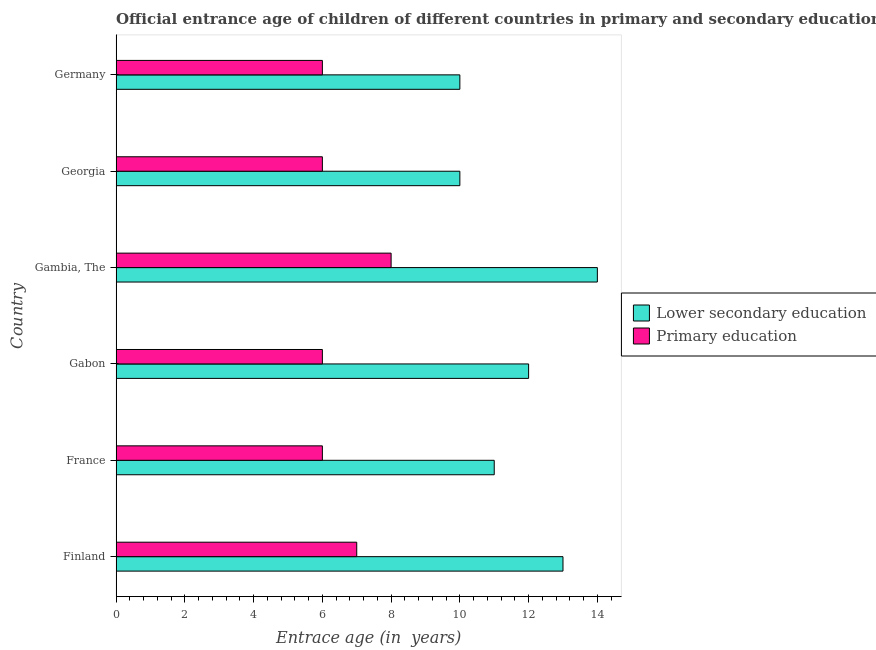How many different coloured bars are there?
Your response must be concise. 2. How many bars are there on the 4th tick from the bottom?
Your answer should be very brief. 2. What is the label of the 4th group of bars from the top?
Keep it short and to the point. Gabon. In how many cases, is the number of bars for a given country not equal to the number of legend labels?
Provide a succinct answer. 0. What is the entrance age of children in lower secondary education in Gabon?
Your answer should be very brief. 12. Across all countries, what is the maximum entrance age of chiildren in primary education?
Your response must be concise. 8. Across all countries, what is the minimum entrance age of chiildren in primary education?
Your answer should be compact. 6. In which country was the entrance age of chiildren in primary education maximum?
Your answer should be compact. Gambia, The. In which country was the entrance age of children in lower secondary education minimum?
Make the answer very short. Georgia. What is the total entrance age of children in lower secondary education in the graph?
Give a very brief answer. 70. What is the difference between the entrance age of children in lower secondary education in France and that in Gambia, The?
Provide a succinct answer. -3. What is the difference between the entrance age of children in lower secondary education in Georgia and the entrance age of chiildren in primary education in Gabon?
Ensure brevity in your answer.  4. What is the average entrance age of children in lower secondary education per country?
Offer a very short reply. 11.67. What is the difference between the entrance age of chiildren in primary education and entrance age of children in lower secondary education in Gambia, The?
Provide a succinct answer. -6. What is the ratio of the entrance age of children in lower secondary education in Gabon to that in Gambia, The?
Your answer should be compact. 0.86. Is the entrance age of chiildren in primary education in France less than that in Georgia?
Provide a succinct answer. No. What is the difference between the highest and the lowest entrance age of chiildren in primary education?
Offer a terse response. 2. Is the sum of the entrance age of children in lower secondary education in France and Gabon greater than the maximum entrance age of chiildren in primary education across all countries?
Your answer should be very brief. Yes. What does the 2nd bar from the top in Gambia, The represents?
Keep it short and to the point. Lower secondary education. What does the 1st bar from the bottom in France represents?
Give a very brief answer. Lower secondary education. How many bars are there?
Provide a succinct answer. 12. Are all the bars in the graph horizontal?
Your answer should be compact. Yes. How many countries are there in the graph?
Offer a very short reply. 6. What is the difference between two consecutive major ticks on the X-axis?
Keep it short and to the point. 2. Are the values on the major ticks of X-axis written in scientific E-notation?
Keep it short and to the point. No. Does the graph contain grids?
Offer a very short reply. No. Where does the legend appear in the graph?
Your answer should be very brief. Center right. How are the legend labels stacked?
Keep it short and to the point. Vertical. What is the title of the graph?
Offer a terse response. Official entrance age of children of different countries in primary and secondary education. What is the label or title of the X-axis?
Your answer should be very brief. Entrace age (in  years). What is the label or title of the Y-axis?
Ensure brevity in your answer.  Country. What is the Entrace age (in  years) of Lower secondary education in Gabon?
Ensure brevity in your answer.  12. What is the Entrace age (in  years) of Primary education in Gambia, The?
Your answer should be compact. 8. What is the Entrace age (in  years) of Lower secondary education in Georgia?
Your answer should be very brief. 10. What is the Entrace age (in  years) of Primary education in Georgia?
Ensure brevity in your answer.  6. What is the Entrace age (in  years) of Lower secondary education in Germany?
Make the answer very short. 10. What is the Entrace age (in  years) in Primary education in Germany?
Offer a very short reply. 6. Across all countries, what is the maximum Entrace age (in  years) in Lower secondary education?
Keep it short and to the point. 14. Across all countries, what is the minimum Entrace age (in  years) in Lower secondary education?
Make the answer very short. 10. What is the difference between the Entrace age (in  years) of Primary education in Finland and that in France?
Keep it short and to the point. 1. What is the difference between the Entrace age (in  years) of Lower secondary education in Finland and that in Gabon?
Offer a terse response. 1. What is the difference between the Entrace age (in  years) in Lower secondary education in Finland and that in Gambia, The?
Ensure brevity in your answer.  -1. What is the difference between the Entrace age (in  years) in Lower secondary education in Finland and that in Georgia?
Keep it short and to the point. 3. What is the difference between the Entrace age (in  years) in Lower secondary education in Finland and that in Germany?
Your answer should be very brief. 3. What is the difference between the Entrace age (in  years) of Primary education in France and that in Gambia, The?
Your answer should be compact. -2. What is the difference between the Entrace age (in  years) of Lower secondary education in France and that in Georgia?
Offer a very short reply. 1. What is the difference between the Entrace age (in  years) in Lower secondary education in Gabon and that in Gambia, The?
Keep it short and to the point. -2. What is the difference between the Entrace age (in  years) of Primary education in Gabon and that in Gambia, The?
Keep it short and to the point. -2. What is the difference between the Entrace age (in  years) of Primary education in Gabon and that in Georgia?
Your answer should be very brief. 0. What is the difference between the Entrace age (in  years) of Lower secondary education in Gambia, The and that in Georgia?
Offer a very short reply. 4. What is the difference between the Entrace age (in  years) in Lower secondary education in Gambia, The and that in Germany?
Offer a very short reply. 4. What is the difference between the Entrace age (in  years) of Primary education in Georgia and that in Germany?
Make the answer very short. 0. What is the difference between the Entrace age (in  years) of Lower secondary education in Finland and the Entrace age (in  years) of Primary education in France?
Offer a terse response. 7. What is the difference between the Entrace age (in  years) in Lower secondary education in Finland and the Entrace age (in  years) in Primary education in Gambia, The?
Provide a short and direct response. 5. What is the difference between the Entrace age (in  years) in Lower secondary education in Finland and the Entrace age (in  years) in Primary education in Germany?
Provide a short and direct response. 7. What is the difference between the Entrace age (in  years) of Lower secondary education in France and the Entrace age (in  years) of Primary education in Gabon?
Offer a very short reply. 5. What is the difference between the Entrace age (in  years) in Lower secondary education in France and the Entrace age (in  years) in Primary education in Gambia, The?
Ensure brevity in your answer.  3. What is the difference between the Entrace age (in  years) of Lower secondary education in France and the Entrace age (in  years) of Primary education in Georgia?
Your answer should be compact. 5. What is the difference between the Entrace age (in  years) of Lower secondary education in Gabon and the Entrace age (in  years) of Primary education in Gambia, The?
Offer a terse response. 4. What is the difference between the Entrace age (in  years) in Lower secondary education in Gabon and the Entrace age (in  years) in Primary education in Georgia?
Your response must be concise. 6. What is the difference between the Entrace age (in  years) of Lower secondary education in Gambia, The and the Entrace age (in  years) of Primary education in Georgia?
Make the answer very short. 8. What is the difference between the Entrace age (in  years) in Lower secondary education in Gambia, The and the Entrace age (in  years) in Primary education in Germany?
Make the answer very short. 8. What is the average Entrace age (in  years) in Lower secondary education per country?
Offer a terse response. 11.67. What is the difference between the Entrace age (in  years) of Lower secondary education and Entrace age (in  years) of Primary education in France?
Offer a very short reply. 5. What is the difference between the Entrace age (in  years) in Lower secondary education and Entrace age (in  years) in Primary education in Gambia, The?
Ensure brevity in your answer.  6. What is the difference between the Entrace age (in  years) of Lower secondary education and Entrace age (in  years) of Primary education in Germany?
Make the answer very short. 4. What is the ratio of the Entrace age (in  years) in Lower secondary education in Finland to that in France?
Provide a succinct answer. 1.18. What is the ratio of the Entrace age (in  years) of Primary education in Finland to that in France?
Your answer should be very brief. 1.17. What is the ratio of the Entrace age (in  years) in Lower secondary education in Finland to that in Gabon?
Give a very brief answer. 1.08. What is the ratio of the Entrace age (in  years) in Primary education in Finland to that in Gambia, The?
Your response must be concise. 0.88. What is the ratio of the Entrace age (in  years) in Lower secondary education in Finland to that in Georgia?
Your response must be concise. 1.3. What is the ratio of the Entrace age (in  years) in Primary education in Finland to that in Georgia?
Your answer should be very brief. 1.17. What is the ratio of the Entrace age (in  years) in Primary education in Finland to that in Germany?
Your response must be concise. 1.17. What is the ratio of the Entrace age (in  years) of Primary education in France to that in Gabon?
Ensure brevity in your answer.  1. What is the ratio of the Entrace age (in  years) in Lower secondary education in France to that in Gambia, The?
Keep it short and to the point. 0.79. What is the ratio of the Entrace age (in  years) of Lower secondary education in France to that in Georgia?
Your response must be concise. 1.1. What is the ratio of the Entrace age (in  years) of Lower secondary education in France to that in Germany?
Offer a very short reply. 1.1. What is the ratio of the Entrace age (in  years) in Primary education in France to that in Germany?
Provide a succinct answer. 1. What is the ratio of the Entrace age (in  years) of Lower secondary education in Gambia, The to that in Georgia?
Your response must be concise. 1.4. What is the ratio of the Entrace age (in  years) of Primary education in Gambia, The to that in Georgia?
Your answer should be compact. 1.33. What is the ratio of the Entrace age (in  years) of Lower secondary education in Gambia, The to that in Germany?
Your answer should be compact. 1.4. What is the ratio of the Entrace age (in  years) of Lower secondary education in Georgia to that in Germany?
Make the answer very short. 1. What is the ratio of the Entrace age (in  years) of Primary education in Georgia to that in Germany?
Offer a terse response. 1. What is the difference between the highest and the second highest Entrace age (in  years) of Lower secondary education?
Give a very brief answer. 1. What is the difference between the highest and the second highest Entrace age (in  years) of Primary education?
Give a very brief answer. 1. What is the difference between the highest and the lowest Entrace age (in  years) in Lower secondary education?
Ensure brevity in your answer.  4. What is the difference between the highest and the lowest Entrace age (in  years) of Primary education?
Your answer should be very brief. 2. 